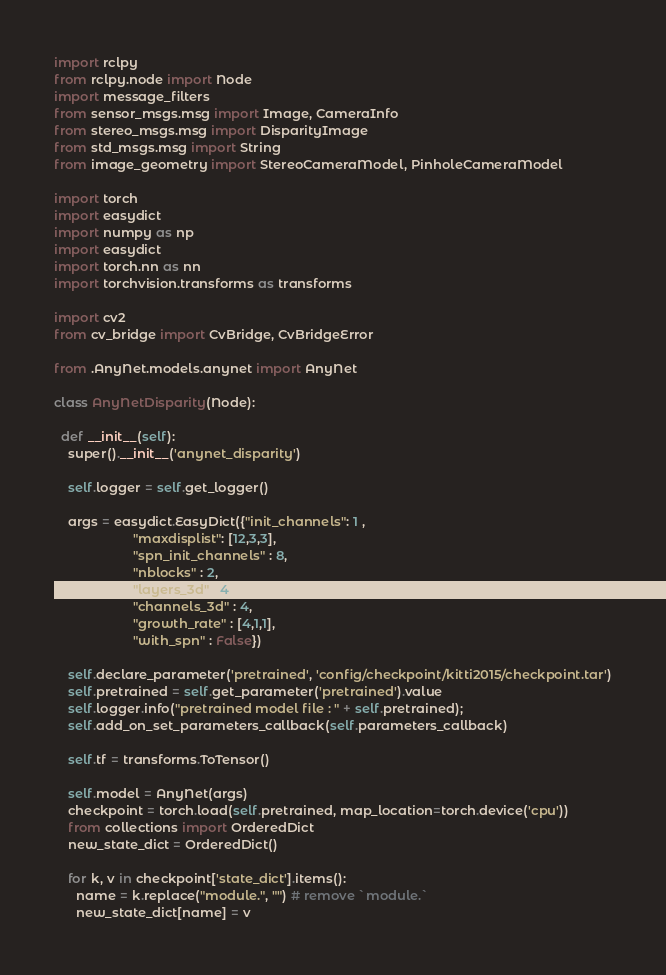Convert code to text. <code><loc_0><loc_0><loc_500><loc_500><_Python_>import rclpy
from rclpy.node import Node
import message_filters
from sensor_msgs.msg import Image, CameraInfo
from stereo_msgs.msg import DisparityImage
from std_msgs.msg import String
from image_geometry import StereoCameraModel, PinholeCameraModel

import torch
import easydict
import numpy as np
import easydict
import torch.nn as nn
import torchvision.transforms as transforms

import cv2
from cv_bridge import CvBridge, CvBridgeError

from .AnyNet.models.anynet import AnyNet

class AnyNetDisparity(Node):

  def __init__(self):
    super().__init__('anynet_disparity')

    self.logger = self.get_logger()

    args = easydict.EasyDict({"init_channels": 1 , 
                      "maxdisplist": [12,3,3],  
                      "spn_init_channels" : 8,
                      "nblocks" : 2,
                      "layers_3d" : 4,
                      "channels_3d" : 4,
                      "growth_rate" : [4,1,1],
                      "with_spn" : False})

    self.declare_parameter('pretrained', 'config/checkpoint/kitti2015/checkpoint.tar')
    self.pretrained = self.get_parameter('pretrained').value
    self.logger.info("pretrained model file : " + self.pretrained);
    self.add_on_set_parameters_callback(self.parameters_callback)

    self.tf = transforms.ToTensor()

    self.model = AnyNet(args)
    checkpoint = torch.load(self.pretrained, map_location=torch.device('cpu'))
    from collections import OrderedDict
    new_state_dict = OrderedDict()

    for k, v in checkpoint['state_dict'].items():
      name = k.replace("module.", "") # remove `module.`
      new_state_dict[name] = v
</code> 